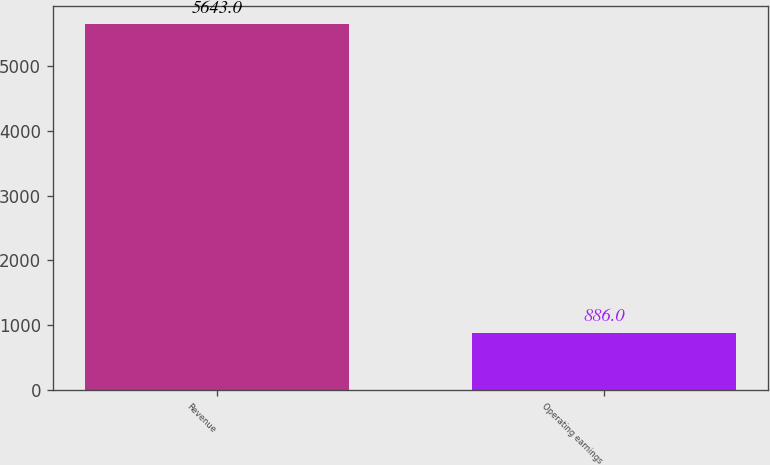<chart> <loc_0><loc_0><loc_500><loc_500><bar_chart><fcel>Revenue<fcel>Operating earnings<nl><fcel>5643<fcel>886<nl></chart> 